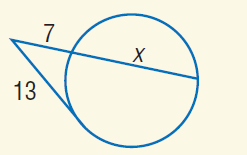Question: Find x to the nearest tenth. Assume that segments that appear to be tangent are tangent.
Choices:
A. 7
B. 13
C. 17.1
D. 21
Answer with the letter. Answer: C 